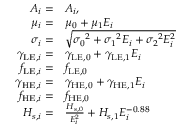Convert formula to latex. <formula><loc_0><loc_0><loc_500><loc_500>\begin{array} { r l } { A _ { i } = } & { A _ { i } , } \\ { \mu _ { i } = } & { \mu _ { 0 } + \mu _ { 1 } E _ { i } } \\ { \sigma _ { i } = } & { \sqrt { \sigma _ { 0 } ^ { 2 } + \sigma _ { 1 } ^ { 2 } E _ { i } + \sigma _ { 2 } ^ { 2 } E _ { i } ^ { 2 } } } \\ { \gamma _ { L E , i } = } & { \gamma _ { L E , 0 } + \gamma _ { L E , 1 } E _ { i } } \\ { f _ { L E , i } = } & { f _ { L E , 0 } } \\ { \gamma _ { H E , i } = } & { \gamma _ { H E , 0 } + \gamma _ { H E , 1 } E _ { i } } \\ { f _ { H E , i } = } & { f _ { H E , 0 } } \\ { H _ { s , i } = } & { \frac { H _ { s , 0 } } { E _ { i } ^ { 2 } } + H _ { s , 1 } E _ { i } ^ { - 0 . 8 8 } } \end{array}</formula> 